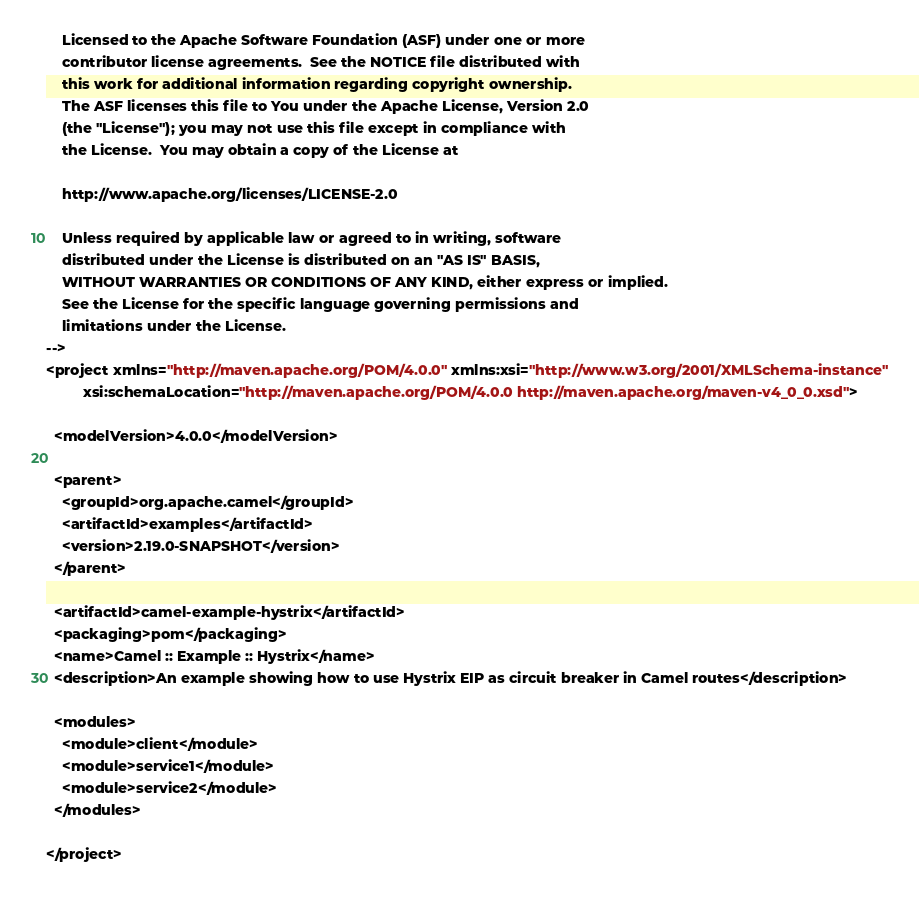Convert code to text. <code><loc_0><loc_0><loc_500><loc_500><_XML_>    Licensed to the Apache Software Foundation (ASF) under one or more
    contributor license agreements.  See the NOTICE file distributed with
    this work for additional information regarding copyright ownership.
    The ASF licenses this file to You under the Apache License, Version 2.0
    (the "License"); you may not use this file except in compliance with
    the License.  You may obtain a copy of the License at

    http://www.apache.org/licenses/LICENSE-2.0

    Unless required by applicable law or agreed to in writing, software
    distributed under the License is distributed on an "AS IS" BASIS,
    WITHOUT WARRANTIES OR CONDITIONS OF ANY KIND, either express or implied.
    See the License for the specific language governing permissions and
    limitations under the License.
-->
<project xmlns="http://maven.apache.org/POM/4.0.0" xmlns:xsi="http://www.w3.org/2001/XMLSchema-instance"
         xsi:schemaLocation="http://maven.apache.org/POM/4.0.0 http://maven.apache.org/maven-v4_0_0.xsd">

  <modelVersion>4.0.0</modelVersion>

  <parent>
    <groupId>org.apache.camel</groupId>
    <artifactId>examples</artifactId>
    <version>2.19.0-SNAPSHOT</version>
  </parent>

  <artifactId>camel-example-hystrix</artifactId>
  <packaging>pom</packaging>
  <name>Camel :: Example :: Hystrix</name>
  <description>An example showing how to use Hystrix EIP as circuit breaker in Camel routes</description>

  <modules>
    <module>client</module>
    <module>service1</module>
    <module>service2</module>
  </modules>

</project>
</code> 